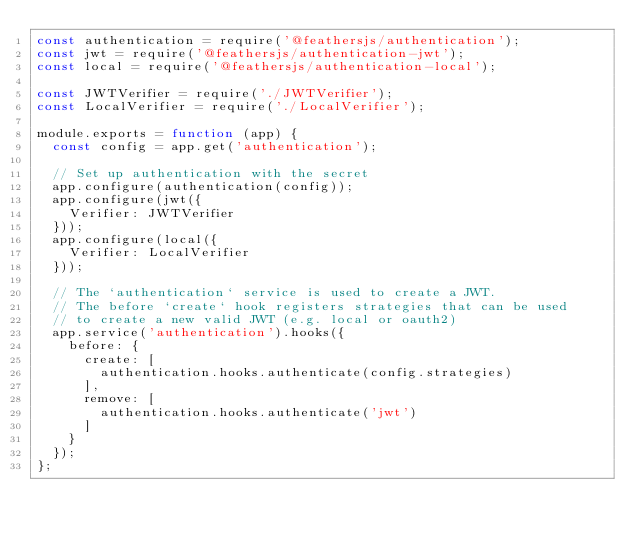Convert code to text. <code><loc_0><loc_0><loc_500><loc_500><_JavaScript_>const authentication = require('@feathersjs/authentication');
const jwt = require('@feathersjs/authentication-jwt');
const local = require('@feathersjs/authentication-local');

const JWTVerifier = require('./JWTVerifier');
const LocalVerifier = require('./LocalVerifier');

module.exports = function (app) {
  const config = app.get('authentication');

  // Set up authentication with the secret
  app.configure(authentication(config));
  app.configure(jwt({
    Verifier: JWTVerifier
  }));
  app.configure(local({
    Verifier: LocalVerifier
  }));

  // The `authentication` service is used to create a JWT.
  // The before `create` hook registers strategies that can be used
  // to create a new valid JWT (e.g. local or oauth2)
  app.service('authentication').hooks({
    before: {
      create: [
        authentication.hooks.authenticate(config.strategies)
      ],
      remove: [
        authentication.hooks.authenticate('jwt')
      ]
    }
  });
};
</code> 